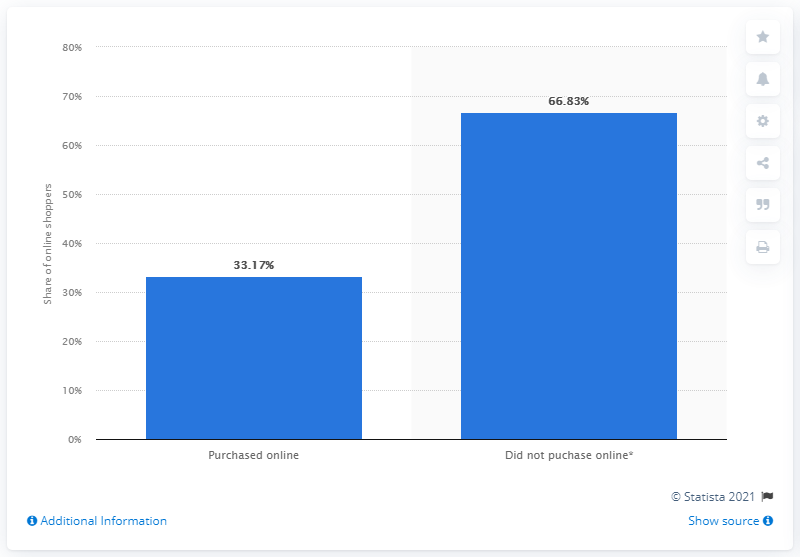Point out several critical features in this image. According to a recent survey, in the first quarter of 2019, 33.17% of internet users in Colombia made online purchases. 